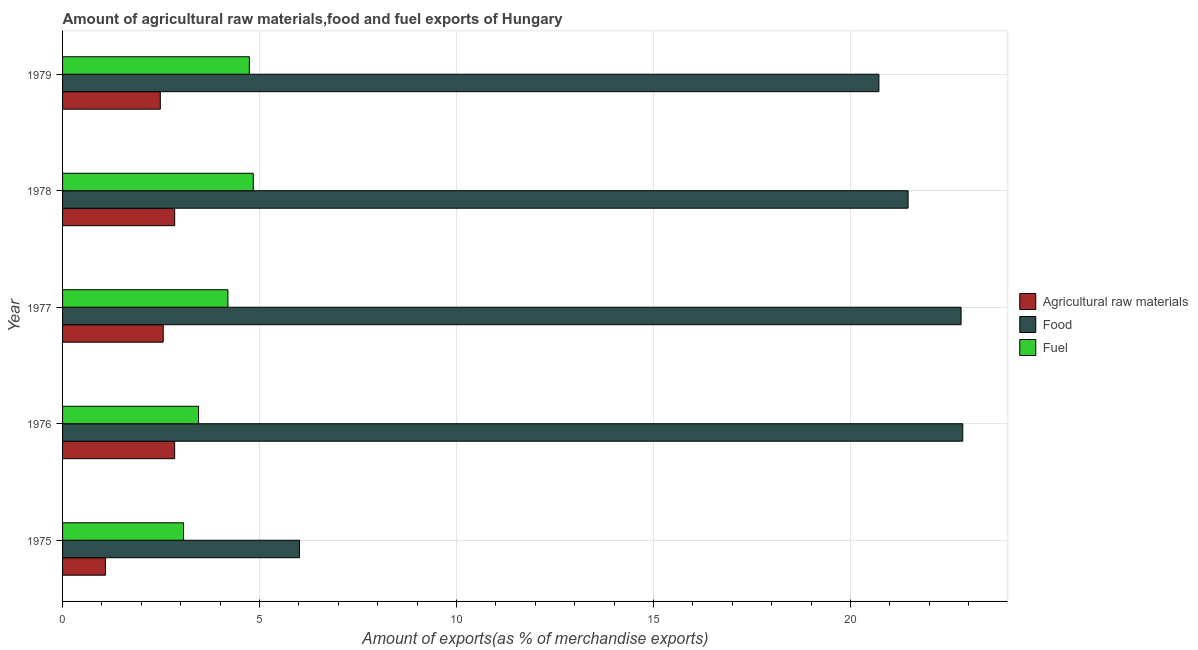How many groups of bars are there?
Keep it short and to the point. 5. Are the number of bars per tick equal to the number of legend labels?
Give a very brief answer. Yes. Are the number of bars on each tick of the Y-axis equal?
Provide a succinct answer. Yes. How many bars are there on the 2nd tick from the top?
Your answer should be very brief. 3. How many bars are there on the 5th tick from the bottom?
Offer a terse response. 3. What is the percentage of food exports in 1979?
Offer a terse response. 20.72. Across all years, what is the maximum percentage of food exports?
Provide a short and direct response. 22.85. Across all years, what is the minimum percentage of food exports?
Provide a succinct answer. 6.01. In which year was the percentage of fuel exports maximum?
Provide a succinct answer. 1978. In which year was the percentage of food exports minimum?
Ensure brevity in your answer.  1975. What is the total percentage of fuel exports in the graph?
Ensure brevity in your answer.  20.3. What is the difference between the percentage of raw materials exports in 1975 and that in 1979?
Your response must be concise. -1.39. What is the difference between the percentage of food exports in 1977 and the percentage of fuel exports in 1976?
Offer a terse response. 19.36. What is the average percentage of food exports per year?
Provide a short and direct response. 18.77. In the year 1976, what is the difference between the percentage of fuel exports and percentage of food exports?
Provide a succinct answer. -19.4. In how many years, is the percentage of raw materials exports greater than 17 %?
Your answer should be compact. 0. What is the ratio of the percentage of raw materials exports in 1975 to that in 1976?
Provide a succinct answer. 0.38. What is the difference between the highest and the second highest percentage of raw materials exports?
Keep it short and to the point. 0. What is the difference between the highest and the lowest percentage of fuel exports?
Your answer should be very brief. 1.77. In how many years, is the percentage of food exports greater than the average percentage of food exports taken over all years?
Give a very brief answer. 4. Is the sum of the percentage of raw materials exports in 1977 and 1979 greater than the maximum percentage of fuel exports across all years?
Your response must be concise. Yes. What does the 2nd bar from the top in 1977 represents?
Make the answer very short. Food. What does the 1st bar from the bottom in 1975 represents?
Make the answer very short. Agricultural raw materials. Is it the case that in every year, the sum of the percentage of raw materials exports and percentage of food exports is greater than the percentage of fuel exports?
Make the answer very short. Yes. How many bars are there?
Your answer should be compact. 15. What is the difference between two consecutive major ticks on the X-axis?
Give a very brief answer. 5. Does the graph contain any zero values?
Your answer should be very brief. No. How many legend labels are there?
Your answer should be very brief. 3. What is the title of the graph?
Your answer should be compact. Amount of agricultural raw materials,food and fuel exports of Hungary. Does "Self-employed" appear as one of the legend labels in the graph?
Provide a short and direct response. No. What is the label or title of the X-axis?
Give a very brief answer. Amount of exports(as % of merchandise exports). What is the label or title of the Y-axis?
Your response must be concise. Year. What is the Amount of exports(as % of merchandise exports) of Agricultural raw materials in 1975?
Offer a very short reply. 1.09. What is the Amount of exports(as % of merchandise exports) in Food in 1975?
Your response must be concise. 6.01. What is the Amount of exports(as % of merchandise exports) in Fuel in 1975?
Ensure brevity in your answer.  3.07. What is the Amount of exports(as % of merchandise exports) in Agricultural raw materials in 1976?
Give a very brief answer. 2.85. What is the Amount of exports(as % of merchandise exports) of Food in 1976?
Your answer should be compact. 22.85. What is the Amount of exports(as % of merchandise exports) of Fuel in 1976?
Provide a succinct answer. 3.45. What is the Amount of exports(as % of merchandise exports) of Agricultural raw materials in 1977?
Offer a very short reply. 2.55. What is the Amount of exports(as % of merchandise exports) of Food in 1977?
Your answer should be very brief. 22.81. What is the Amount of exports(as % of merchandise exports) in Fuel in 1977?
Offer a very short reply. 4.2. What is the Amount of exports(as % of merchandise exports) of Agricultural raw materials in 1978?
Offer a terse response. 2.85. What is the Amount of exports(as % of merchandise exports) in Food in 1978?
Offer a very short reply. 21.46. What is the Amount of exports(as % of merchandise exports) in Fuel in 1978?
Ensure brevity in your answer.  4.84. What is the Amount of exports(as % of merchandise exports) in Agricultural raw materials in 1979?
Offer a terse response. 2.48. What is the Amount of exports(as % of merchandise exports) in Food in 1979?
Give a very brief answer. 20.72. What is the Amount of exports(as % of merchandise exports) of Fuel in 1979?
Your response must be concise. 4.74. Across all years, what is the maximum Amount of exports(as % of merchandise exports) in Agricultural raw materials?
Give a very brief answer. 2.85. Across all years, what is the maximum Amount of exports(as % of merchandise exports) in Food?
Provide a succinct answer. 22.85. Across all years, what is the maximum Amount of exports(as % of merchandise exports) of Fuel?
Ensure brevity in your answer.  4.84. Across all years, what is the minimum Amount of exports(as % of merchandise exports) of Agricultural raw materials?
Provide a succinct answer. 1.09. Across all years, what is the minimum Amount of exports(as % of merchandise exports) of Food?
Make the answer very short. 6.01. Across all years, what is the minimum Amount of exports(as % of merchandise exports) in Fuel?
Your answer should be very brief. 3.07. What is the total Amount of exports(as % of merchandise exports) in Agricultural raw materials in the graph?
Your answer should be compact. 11.82. What is the total Amount of exports(as % of merchandise exports) of Food in the graph?
Your response must be concise. 93.85. What is the total Amount of exports(as % of merchandise exports) in Fuel in the graph?
Keep it short and to the point. 20.3. What is the difference between the Amount of exports(as % of merchandise exports) in Agricultural raw materials in 1975 and that in 1976?
Keep it short and to the point. -1.76. What is the difference between the Amount of exports(as % of merchandise exports) in Food in 1975 and that in 1976?
Ensure brevity in your answer.  -16.83. What is the difference between the Amount of exports(as % of merchandise exports) in Fuel in 1975 and that in 1976?
Make the answer very short. -0.38. What is the difference between the Amount of exports(as % of merchandise exports) of Agricultural raw materials in 1975 and that in 1977?
Provide a succinct answer. -1.47. What is the difference between the Amount of exports(as % of merchandise exports) of Food in 1975 and that in 1977?
Your answer should be very brief. -16.79. What is the difference between the Amount of exports(as % of merchandise exports) of Fuel in 1975 and that in 1977?
Ensure brevity in your answer.  -1.13. What is the difference between the Amount of exports(as % of merchandise exports) in Agricultural raw materials in 1975 and that in 1978?
Give a very brief answer. -1.76. What is the difference between the Amount of exports(as % of merchandise exports) in Food in 1975 and that in 1978?
Your answer should be very brief. -15.45. What is the difference between the Amount of exports(as % of merchandise exports) of Fuel in 1975 and that in 1978?
Provide a succinct answer. -1.77. What is the difference between the Amount of exports(as % of merchandise exports) in Agricultural raw materials in 1975 and that in 1979?
Your response must be concise. -1.39. What is the difference between the Amount of exports(as % of merchandise exports) of Food in 1975 and that in 1979?
Keep it short and to the point. -14.71. What is the difference between the Amount of exports(as % of merchandise exports) in Fuel in 1975 and that in 1979?
Make the answer very short. -1.67. What is the difference between the Amount of exports(as % of merchandise exports) in Agricultural raw materials in 1976 and that in 1977?
Provide a short and direct response. 0.29. What is the difference between the Amount of exports(as % of merchandise exports) of Food in 1976 and that in 1977?
Make the answer very short. 0.04. What is the difference between the Amount of exports(as % of merchandise exports) in Fuel in 1976 and that in 1977?
Keep it short and to the point. -0.75. What is the difference between the Amount of exports(as % of merchandise exports) in Agricultural raw materials in 1976 and that in 1978?
Provide a succinct answer. -0. What is the difference between the Amount of exports(as % of merchandise exports) in Food in 1976 and that in 1978?
Your response must be concise. 1.39. What is the difference between the Amount of exports(as % of merchandise exports) in Fuel in 1976 and that in 1978?
Keep it short and to the point. -1.39. What is the difference between the Amount of exports(as % of merchandise exports) in Agricultural raw materials in 1976 and that in 1979?
Make the answer very short. 0.36. What is the difference between the Amount of exports(as % of merchandise exports) in Food in 1976 and that in 1979?
Ensure brevity in your answer.  2.13. What is the difference between the Amount of exports(as % of merchandise exports) in Fuel in 1976 and that in 1979?
Ensure brevity in your answer.  -1.29. What is the difference between the Amount of exports(as % of merchandise exports) of Agricultural raw materials in 1977 and that in 1978?
Give a very brief answer. -0.29. What is the difference between the Amount of exports(as % of merchandise exports) in Food in 1977 and that in 1978?
Provide a succinct answer. 1.35. What is the difference between the Amount of exports(as % of merchandise exports) of Fuel in 1977 and that in 1978?
Make the answer very short. -0.64. What is the difference between the Amount of exports(as % of merchandise exports) of Agricultural raw materials in 1977 and that in 1979?
Make the answer very short. 0.07. What is the difference between the Amount of exports(as % of merchandise exports) of Food in 1977 and that in 1979?
Make the answer very short. 2.09. What is the difference between the Amount of exports(as % of merchandise exports) of Fuel in 1977 and that in 1979?
Provide a succinct answer. -0.54. What is the difference between the Amount of exports(as % of merchandise exports) of Agricultural raw materials in 1978 and that in 1979?
Offer a terse response. 0.36. What is the difference between the Amount of exports(as % of merchandise exports) in Food in 1978 and that in 1979?
Offer a very short reply. 0.74. What is the difference between the Amount of exports(as % of merchandise exports) of Fuel in 1978 and that in 1979?
Provide a short and direct response. 0.1. What is the difference between the Amount of exports(as % of merchandise exports) of Agricultural raw materials in 1975 and the Amount of exports(as % of merchandise exports) of Food in 1976?
Your answer should be very brief. -21.76. What is the difference between the Amount of exports(as % of merchandise exports) of Agricultural raw materials in 1975 and the Amount of exports(as % of merchandise exports) of Fuel in 1976?
Your answer should be compact. -2.36. What is the difference between the Amount of exports(as % of merchandise exports) in Food in 1975 and the Amount of exports(as % of merchandise exports) in Fuel in 1976?
Provide a succinct answer. 2.56. What is the difference between the Amount of exports(as % of merchandise exports) of Agricultural raw materials in 1975 and the Amount of exports(as % of merchandise exports) of Food in 1977?
Make the answer very short. -21.72. What is the difference between the Amount of exports(as % of merchandise exports) in Agricultural raw materials in 1975 and the Amount of exports(as % of merchandise exports) in Fuel in 1977?
Your response must be concise. -3.11. What is the difference between the Amount of exports(as % of merchandise exports) of Food in 1975 and the Amount of exports(as % of merchandise exports) of Fuel in 1977?
Ensure brevity in your answer.  1.82. What is the difference between the Amount of exports(as % of merchandise exports) of Agricultural raw materials in 1975 and the Amount of exports(as % of merchandise exports) of Food in 1978?
Offer a very short reply. -20.37. What is the difference between the Amount of exports(as % of merchandise exports) of Agricultural raw materials in 1975 and the Amount of exports(as % of merchandise exports) of Fuel in 1978?
Ensure brevity in your answer.  -3.75. What is the difference between the Amount of exports(as % of merchandise exports) in Food in 1975 and the Amount of exports(as % of merchandise exports) in Fuel in 1978?
Your answer should be compact. 1.17. What is the difference between the Amount of exports(as % of merchandise exports) of Agricultural raw materials in 1975 and the Amount of exports(as % of merchandise exports) of Food in 1979?
Give a very brief answer. -19.63. What is the difference between the Amount of exports(as % of merchandise exports) of Agricultural raw materials in 1975 and the Amount of exports(as % of merchandise exports) of Fuel in 1979?
Your answer should be very brief. -3.65. What is the difference between the Amount of exports(as % of merchandise exports) in Food in 1975 and the Amount of exports(as % of merchandise exports) in Fuel in 1979?
Your answer should be compact. 1.27. What is the difference between the Amount of exports(as % of merchandise exports) of Agricultural raw materials in 1976 and the Amount of exports(as % of merchandise exports) of Food in 1977?
Provide a short and direct response. -19.96. What is the difference between the Amount of exports(as % of merchandise exports) of Agricultural raw materials in 1976 and the Amount of exports(as % of merchandise exports) of Fuel in 1977?
Offer a terse response. -1.35. What is the difference between the Amount of exports(as % of merchandise exports) of Food in 1976 and the Amount of exports(as % of merchandise exports) of Fuel in 1977?
Give a very brief answer. 18.65. What is the difference between the Amount of exports(as % of merchandise exports) in Agricultural raw materials in 1976 and the Amount of exports(as % of merchandise exports) in Food in 1978?
Your answer should be very brief. -18.62. What is the difference between the Amount of exports(as % of merchandise exports) of Agricultural raw materials in 1976 and the Amount of exports(as % of merchandise exports) of Fuel in 1978?
Provide a short and direct response. -2. What is the difference between the Amount of exports(as % of merchandise exports) in Food in 1976 and the Amount of exports(as % of merchandise exports) in Fuel in 1978?
Keep it short and to the point. 18.01. What is the difference between the Amount of exports(as % of merchandise exports) of Agricultural raw materials in 1976 and the Amount of exports(as % of merchandise exports) of Food in 1979?
Offer a terse response. -17.88. What is the difference between the Amount of exports(as % of merchandise exports) in Agricultural raw materials in 1976 and the Amount of exports(as % of merchandise exports) in Fuel in 1979?
Ensure brevity in your answer.  -1.9. What is the difference between the Amount of exports(as % of merchandise exports) of Food in 1976 and the Amount of exports(as % of merchandise exports) of Fuel in 1979?
Offer a terse response. 18.11. What is the difference between the Amount of exports(as % of merchandise exports) of Agricultural raw materials in 1977 and the Amount of exports(as % of merchandise exports) of Food in 1978?
Give a very brief answer. -18.91. What is the difference between the Amount of exports(as % of merchandise exports) of Agricultural raw materials in 1977 and the Amount of exports(as % of merchandise exports) of Fuel in 1978?
Make the answer very short. -2.29. What is the difference between the Amount of exports(as % of merchandise exports) of Food in 1977 and the Amount of exports(as % of merchandise exports) of Fuel in 1978?
Offer a terse response. 17.97. What is the difference between the Amount of exports(as % of merchandise exports) of Agricultural raw materials in 1977 and the Amount of exports(as % of merchandise exports) of Food in 1979?
Provide a succinct answer. -18.17. What is the difference between the Amount of exports(as % of merchandise exports) in Agricultural raw materials in 1977 and the Amount of exports(as % of merchandise exports) in Fuel in 1979?
Your response must be concise. -2.19. What is the difference between the Amount of exports(as % of merchandise exports) of Food in 1977 and the Amount of exports(as % of merchandise exports) of Fuel in 1979?
Your response must be concise. 18.07. What is the difference between the Amount of exports(as % of merchandise exports) of Agricultural raw materials in 1978 and the Amount of exports(as % of merchandise exports) of Food in 1979?
Offer a very short reply. -17.88. What is the difference between the Amount of exports(as % of merchandise exports) of Agricultural raw materials in 1978 and the Amount of exports(as % of merchandise exports) of Fuel in 1979?
Your answer should be very brief. -1.9. What is the difference between the Amount of exports(as % of merchandise exports) in Food in 1978 and the Amount of exports(as % of merchandise exports) in Fuel in 1979?
Make the answer very short. 16.72. What is the average Amount of exports(as % of merchandise exports) in Agricultural raw materials per year?
Keep it short and to the point. 2.36. What is the average Amount of exports(as % of merchandise exports) in Food per year?
Ensure brevity in your answer.  18.77. What is the average Amount of exports(as % of merchandise exports) of Fuel per year?
Your answer should be very brief. 4.06. In the year 1975, what is the difference between the Amount of exports(as % of merchandise exports) in Agricultural raw materials and Amount of exports(as % of merchandise exports) in Food?
Keep it short and to the point. -4.93. In the year 1975, what is the difference between the Amount of exports(as % of merchandise exports) in Agricultural raw materials and Amount of exports(as % of merchandise exports) in Fuel?
Your answer should be compact. -1.98. In the year 1975, what is the difference between the Amount of exports(as % of merchandise exports) in Food and Amount of exports(as % of merchandise exports) in Fuel?
Provide a short and direct response. 2.94. In the year 1976, what is the difference between the Amount of exports(as % of merchandise exports) in Agricultural raw materials and Amount of exports(as % of merchandise exports) in Food?
Your answer should be very brief. -20. In the year 1976, what is the difference between the Amount of exports(as % of merchandise exports) in Agricultural raw materials and Amount of exports(as % of merchandise exports) in Fuel?
Give a very brief answer. -0.61. In the year 1976, what is the difference between the Amount of exports(as % of merchandise exports) in Food and Amount of exports(as % of merchandise exports) in Fuel?
Make the answer very short. 19.4. In the year 1977, what is the difference between the Amount of exports(as % of merchandise exports) of Agricultural raw materials and Amount of exports(as % of merchandise exports) of Food?
Offer a terse response. -20.25. In the year 1977, what is the difference between the Amount of exports(as % of merchandise exports) of Agricultural raw materials and Amount of exports(as % of merchandise exports) of Fuel?
Provide a succinct answer. -1.64. In the year 1977, what is the difference between the Amount of exports(as % of merchandise exports) of Food and Amount of exports(as % of merchandise exports) of Fuel?
Your answer should be very brief. 18.61. In the year 1978, what is the difference between the Amount of exports(as % of merchandise exports) of Agricultural raw materials and Amount of exports(as % of merchandise exports) of Food?
Your answer should be compact. -18.62. In the year 1978, what is the difference between the Amount of exports(as % of merchandise exports) of Agricultural raw materials and Amount of exports(as % of merchandise exports) of Fuel?
Make the answer very short. -1.99. In the year 1978, what is the difference between the Amount of exports(as % of merchandise exports) of Food and Amount of exports(as % of merchandise exports) of Fuel?
Give a very brief answer. 16.62. In the year 1979, what is the difference between the Amount of exports(as % of merchandise exports) of Agricultural raw materials and Amount of exports(as % of merchandise exports) of Food?
Provide a short and direct response. -18.24. In the year 1979, what is the difference between the Amount of exports(as % of merchandise exports) of Agricultural raw materials and Amount of exports(as % of merchandise exports) of Fuel?
Offer a terse response. -2.26. In the year 1979, what is the difference between the Amount of exports(as % of merchandise exports) in Food and Amount of exports(as % of merchandise exports) in Fuel?
Your answer should be very brief. 15.98. What is the ratio of the Amount of exports(as % of merchandise exports) of Agricultural raw materials in 1975 to that in 1976?
Make the answer very short. 0.38. What is the ratio of the Amount of exports(as % of merchandise exports) of Food in 1975 to that in 1976?
Give a very brief answer. 0.26. What is the ratio of the Amount of exports(as % of merchandise exports) in Fuel in 1975 to that in 1976?
Ensure brevity in your answer.  0.89. What is the ratio of the Amount of exports(as % of merchandise exports) in Agricultural raw materials in 1975 to that in 1977?
Your response must be concise. 0.43. What is the ratio of the Amount of exports(as % of merchandise exports) in Food in 1975 to that in 1977?
Make the answer very short. 0.26. What is the ratio of the Amount of exports(as % of merchandise exports) in Fuel in 1975 to that in 1977?
Offer a very short reply. 0.73. What is the ratio of the Amount of exports(as % of merchandise exports) in Agricultural raw materials in 1975 to that in 1978?
Offer a terse response. 0.38. What is the ratio of the Amount of exports(as % of merchandise exports) in Food in 1975 to that in 1978?
Provide a short and direct response. 0.28. What is the ratio of the Amount of exports(as % of merchandise exports) in Fuel in 1975 to that in 1978?
Offer a very short reply. 0.63. What is the ratio of the Amount of exports(as % of merchandise exports) of Agricultural raw materials in 1975 to that in 1979?
Ensure brevity in your answer.  0.44. What is the ratio of the Amount of exports(as % of merchandise exports) in Food in 1975 to that in 1979?
Provide a succinct answer. 0.29. What is the ratio of the Amount of exports(as % of merchandise exports) in Fuel in 1975 to that in 1979?
Your answer should be compact. 0.65. What is the ratio of the Amount of exports(as % of merchandise exports) in Agricultural raw materials in 1976 to that in 1977?
Provide a succinct answer. 1.11. What is the ratio of the Amount of exports(as % of merchandise exports) in Food in 1976 to that in 1977?
Offer a very short reply. 1. What is the ratio of the Amount of exports(as % of merchandise exports) of Fuel in 1976 to that in 1977?
Offer a very short reply. 0.82. What is the ratio of the Amount of exports(as % of merchandise exports) of Agricultural raw materials in 1976 to that in 1978?
Provide a succinct answer. 1. What is the ratio of the Amount of exports(as % of merchandise exports) in Food in 1976 to that in 1978?
Offer a terse response. 1.06. What is the ratio of the Amount of exports(as % of merchandise exports) in Fuel in 1976 to that in 1978?
Your answer should be compact. 0.71. What is the ratio of the Amount of exports(as % of merchandise exports) of Agricultural raw materials in 1976 to that in 1979?
Ensure brevity in your answer.  1.15. What is the ratio of the Amount of exports(as % of merchandise exports) in Food in 1976 to that in 1979?
Provide a succinct answer. 1.1. What is the ratio of the Amount of exports(as % of merchandise exports) of Fuel in 1976 to that in 1979?
Ensure brevity in your answer.  0.73. What is the ratio of the Amount of exports(as % of merchandise exports) of Agricultural raw materials in 1977 to that in 1978?
Keep it short and to the point. 0.9. What is the ratio of the Amount of exports(as % of merchandise exports) of Food in 1977 to that in 1978?
Provide a short and direct response. 1.06. What is the ratio of the Amount of exports(as % of merchandise exports) of Fuel in 1977 to that in 1978?
Your response must be concise. 0.87. What is the ratio of the Amount of exports(as % of merchandise exports) in Agricultural raw materials in 1977 to that in 1979?
Make the answer very short. 1.03. What is the ratio of the Amount of exports(as % of merchandise exports) in Food in 1977 to that in 1979?
Provide a short and direct response. 1.1. What is the ratio of the Amount of exports(as % of merchandise exports) of Fuel in 1977 to that in 1979?
Offer a terse response. 0.89. What is the ratio of the Amount of exports(as % of merchandise exports) in Agricultural raw materials in 1978 to that in 1979?
Provide a short and direct response. 1.15. What is the ratio of the Amount of exports(as % of merchandise exports) in Food in 1978 to that in 1979?
Ensure brevity in your answer.  1.04. What is the ratio of the Amount of exports(as % of merchandise exports) in Fuel in 1978 to that in 1979?
Provide a succinct answer. 1.02. What is the difference between the highest and the second highest Amount of exports(as % of merchandise exports) in Agricultural raw materials?
Offer a terse response. 0. What is the difference between the highest and the second highest Amount of exports(as % of merchandise exports) in Food?
Give a very brief answer. 0.04. What is the difference between the highest and the second highest Amount of exports(as % of merchandise exports) of Fuel?
Ensure brevity in your answer.  0.1. What is the difference between the highest and the lowest Amount of exports(as % of merchandise exports) in Agricultural raw materials?
Offer a terse response. 1.76. What is the difference between the highest and the lowest Amount of exports(as % of merchandise exports) of Food?
Provide a short and direct response. 16.83. What is the difference between the highest and the lowest Amount of exports(as % of merchandise exports) in Fuel?
Offer a terse response. 1.77. 